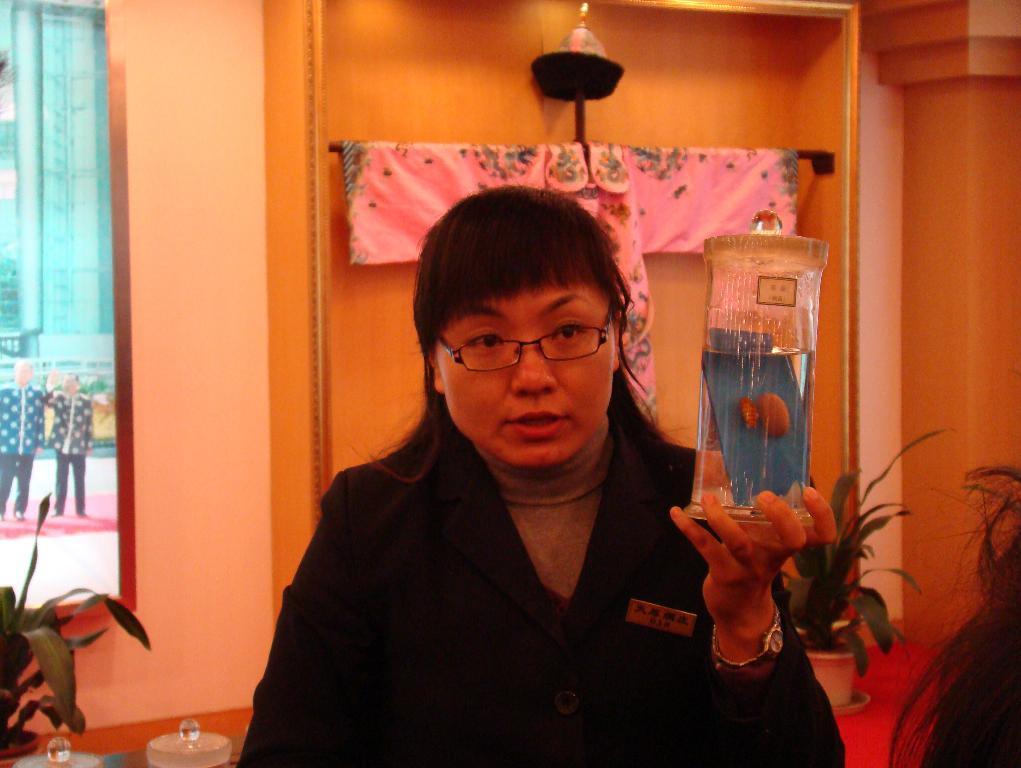Please provide a concise description of this image. In this picture, we can see a few people, and among them we can see a person holding an object, we can see the wall, with glass window, some objects in the background, we can see some objects in the bottom left side of the picture, we can see the ground and some objects from the glass window. 